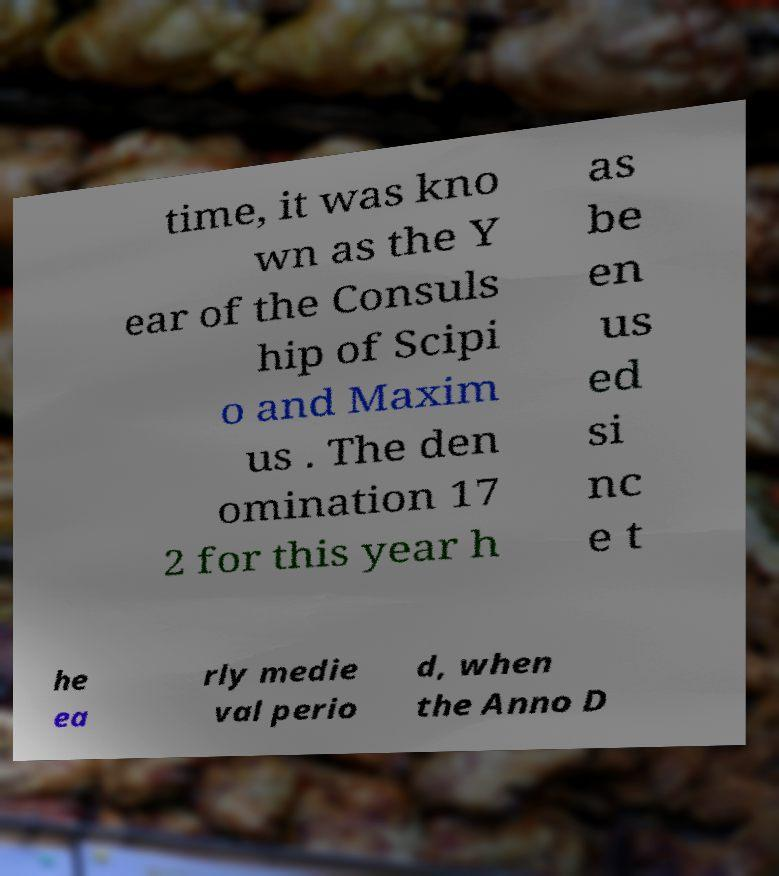Can you accurately transcribe the text from the provided image for me? time, it was kno wn as the Y ear of the Consuls hip of Scipi o and Maxim us . The den omination 17 2 for this year h as be en us ed si nc e t he ea rly medie val perio d, when the Anno D 